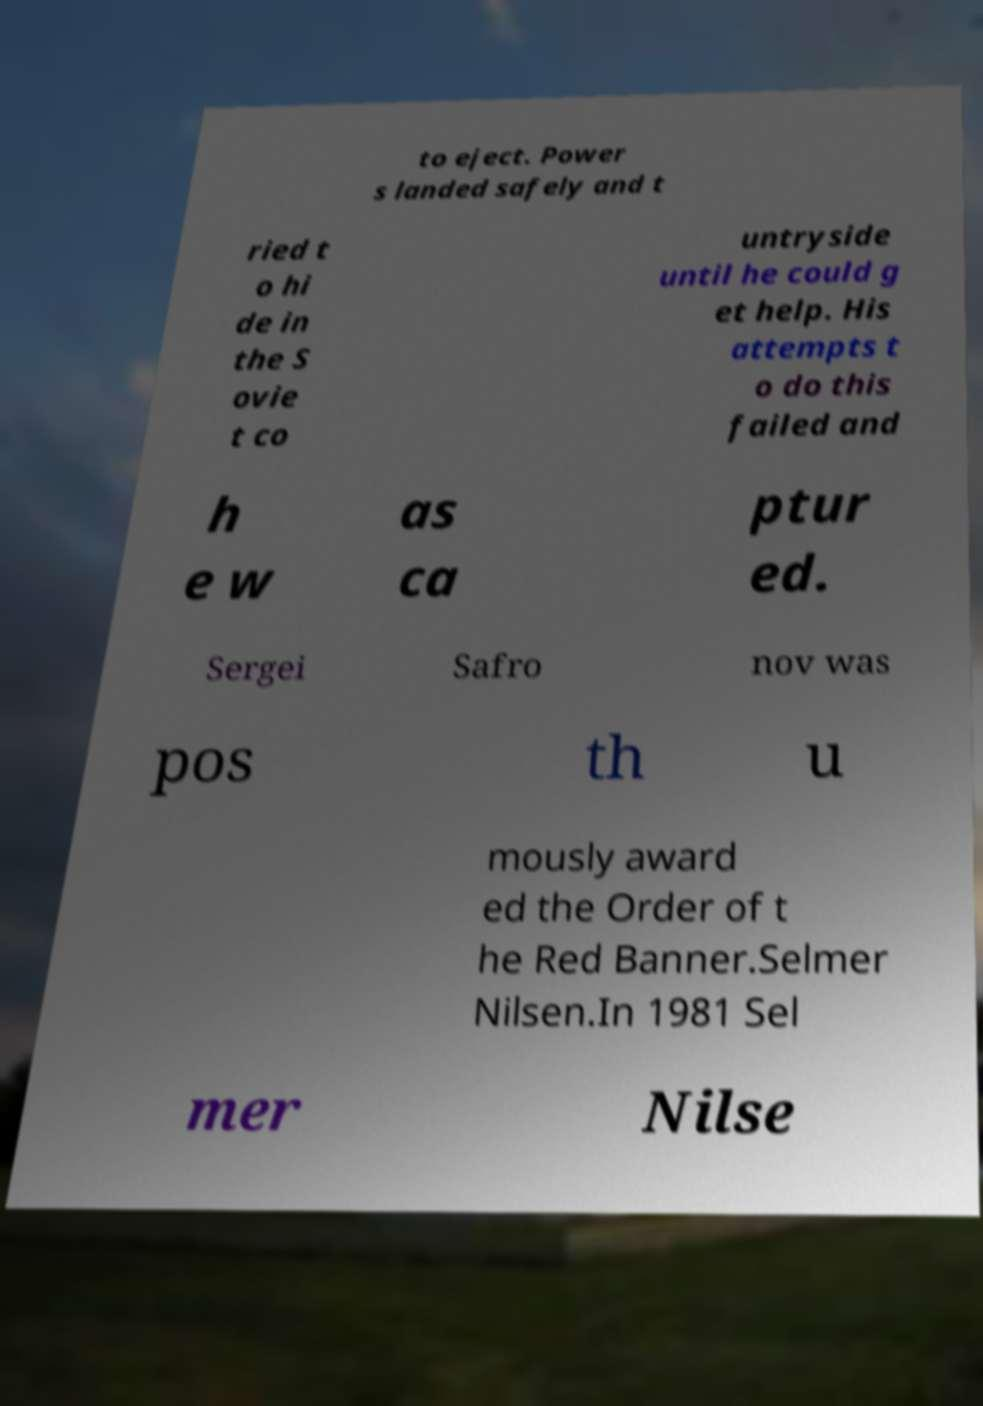Could you extract and type out the text from this image? to eject. Power s landed safely and t ried t o hi de in the S ovie t co untryside until he could g et help. His attempts t o do this failed and h e w as ca ptur ed. Sergei Safro nov was pos th u mously award ed the Order of t he Red Banner.Selmer Nilsen.In 1981 Sel mer Nilse 